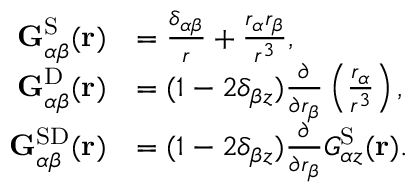<formula> <loc_0><loc_0><loc_500><loc_500>\begin{array} { r l } { G _ { \alpha \beta } ^ { S } ( r ) } & { = \frac { \delta _ { \alpha \beta } } { r } + \frac { r _ { \alpha } r _ { \beta } } { r ^ { 3 } } , } \\ { G _ { \alpha \beta } ^ { D } ( r ) } & { = ( 1 - 2 \delta _ { \beta z } ) \frac { \partial } { \partial r _ { \beta } } \left ( \frac { r _ { \alpha } } { r ^ { 3 } } \right ) , } \\ { G _ { \alpha \beta } ^ { S D } ( r ) } & { = ( 1 - 2 \delta _ { \beta z } ) \frac { \partial } { \partial r _ { \beta } } G _ { \alpha z } ^ { S } ( r ) . } \end{array}</formula> 